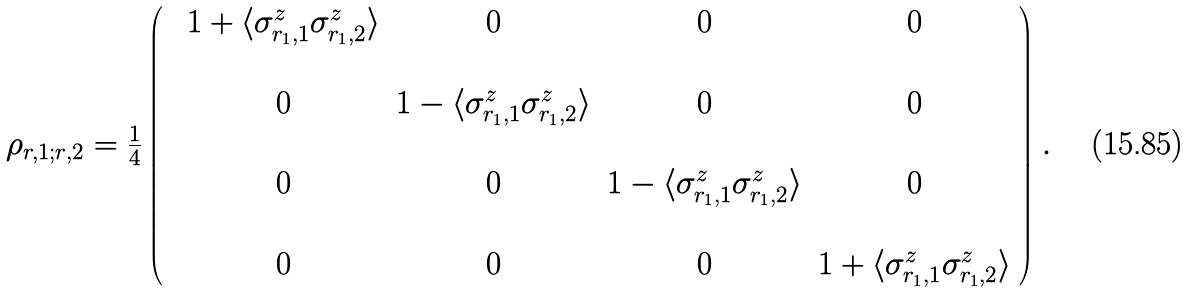<formula> <loc_0><loc_0><loc_500><loc_500>\begin{array} { c c c c } \rho _ { r , 1 ; r , 2 } = \frac { 1 } { 4 } \left ( \begin{array} { c c c c c c c c } & 1 + \langle \sigma ^ { z } _ { r _ { 1 } , 1 } \sigma ^ { z } _ { r _ { 1 } , 2 } \rangle & 0 & 0 & 0 \\ \\ & 0 & 1 - \langle \sigma ^ { z } _ { r _ { 1 } , 1 } \sigma ^ { z } _ { r _ { 1 } , 2 } \rangle & 0 & 0 \\ \\ & 0 & 0 & 1 - \langle \sigma ^ { z } _ { r _ { 1 } , 1 } \sigma ^ { z } _ { r _ { 1 } , 2 } \rangle & 0 \\ \\ & 0 & 0 & 0 & 1 + \langle \sigma ^ { z } _ { r _ { 1 } , 1 } \sigma ^ { z } _ { r _ { 1 } , 2 } \rangle \\ \end{array} \right ) \end{array} .</formula> 